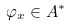Convert formula to latex. <formula><loc_0><loc_0><loc_500><loc_500>\varphi _ { x } \in A ^ { * }</formula> 